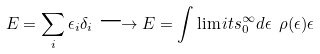<formula> <loc_0><loc_0><loc_500><loc_500>E = \sum _ { i } \epsilon _ { i } \delta _ { i } \longrightarrow E = \int \lim i t s _ { 0 } ^ { \infty } d \epsilon \ \rho ( \epsilon ) \epsilon</formula> 